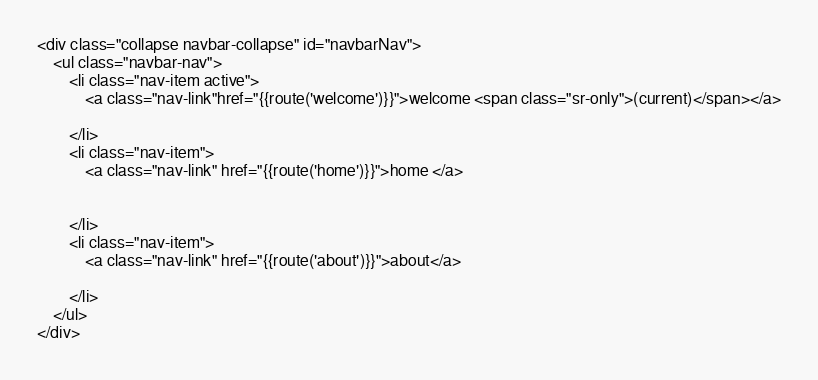Convert code to text. <code><loc_0><loc_0><loc_500><loc_500><_PHP_>
<div class="collapse navbar-collapse" id="navbarNav">
    <ul class="navbar-nav">
        <li class="nav-item active">
            <a class="nav-link"href="{{route('welcome')}}">welcome <span class="sr-only">(current)</span></a>

        </li>
        <li class="nav-item">
            <a class="nav-link" href="{{route('home')}}">home </a>


        </li>
        <li class="nav-item">
            <a class="nav-link" href="{{route('about')}}">about</a>

        </li>
    </ul>
</div>
</code> 